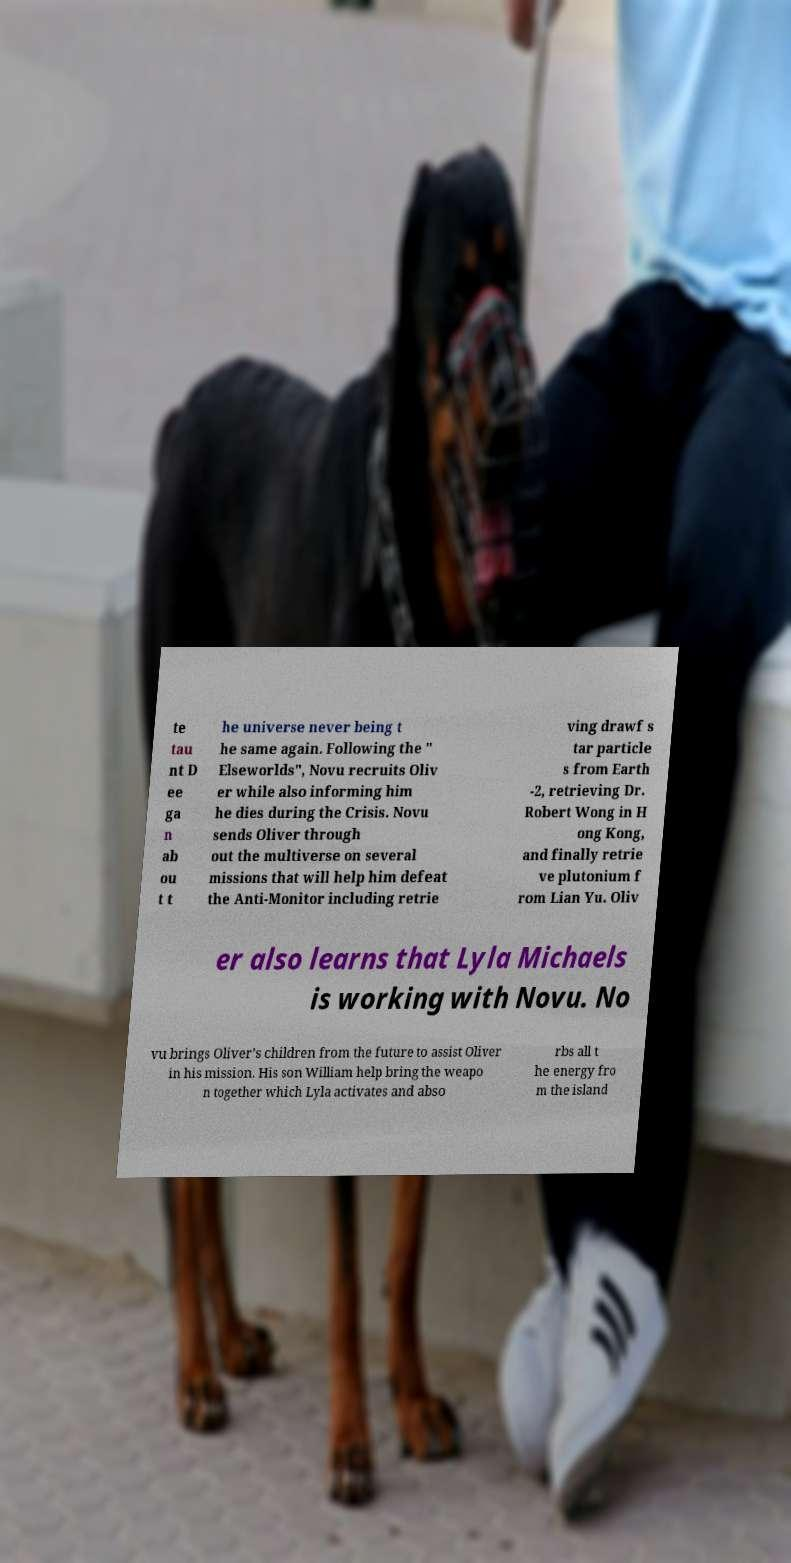Can you accurately transcribe the text from the provided image for me? te tau nt D ee ga n ab ou t t he universe never being t he same again. Following the " Elseworlds", Novu recruits Oliv er while also informing him he dies during the Crisis. Novu sends Oliver through out the multiverse on several missions that will help him defeat the Anti-Monitor including retrie ving drawf s tar particle s from Earth -2, retrieving Dr. Robert Wong in H ong Kong, and finally retrie ve plutonium f rom Lian Yu. Oliv er also learns that Lyla Michaels is working with Novu. No vu brings Oliver’s children from the future to assist Oliver in his mission. His son William help bring the weapo n together which Lyla activates and abso rbs all t he energy fro m the island 